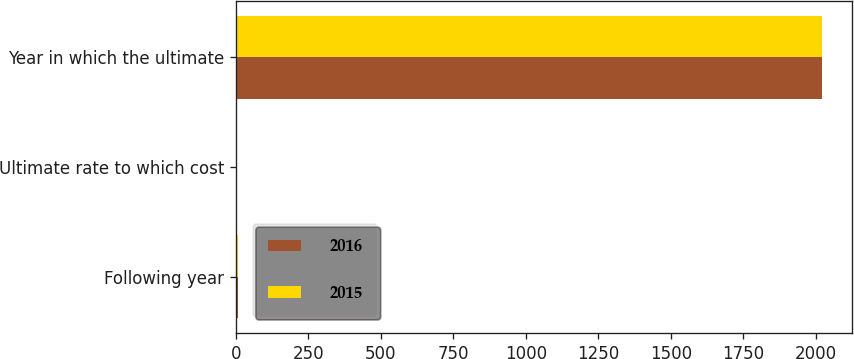Convert chart to OTSL. <chart><loc_0><loc_0><loc_500><loc_500><stacked_bar_chart><ecel><fcel>Following year<fcel>Ultimate rate to which cost<fcel>Year in which the ultimate<nl><fcel>2016<fcel>6.5<fcel>5<fcel>2023<nl><fcel>2015<fcel>7<fcel>5<fcel>2020<nl></chart> 